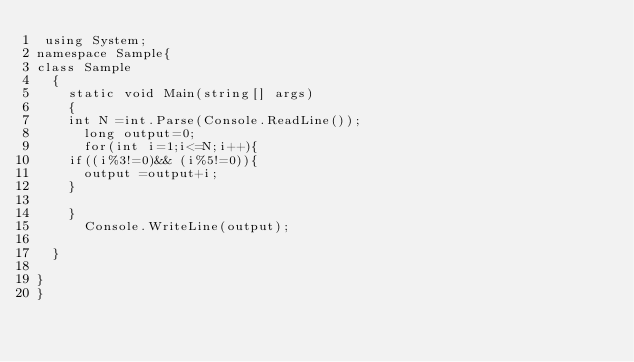<code> <loc_0><loc_0><loc_500><loc_500><_C#_> using System;
namespace Sample{
class Sample
  {
    static void Main(string[] args)
    {
    int N =int.Parse(Console.ReadLine());
      long output=0;
      for(int i=1;i<=N;i++){
    if((i%3!=0)&& (i%5!=0)){
      output =output+i;
    }
 
    }
      Console.WriteLine(output);
    
  }
 
}
}
</code> 